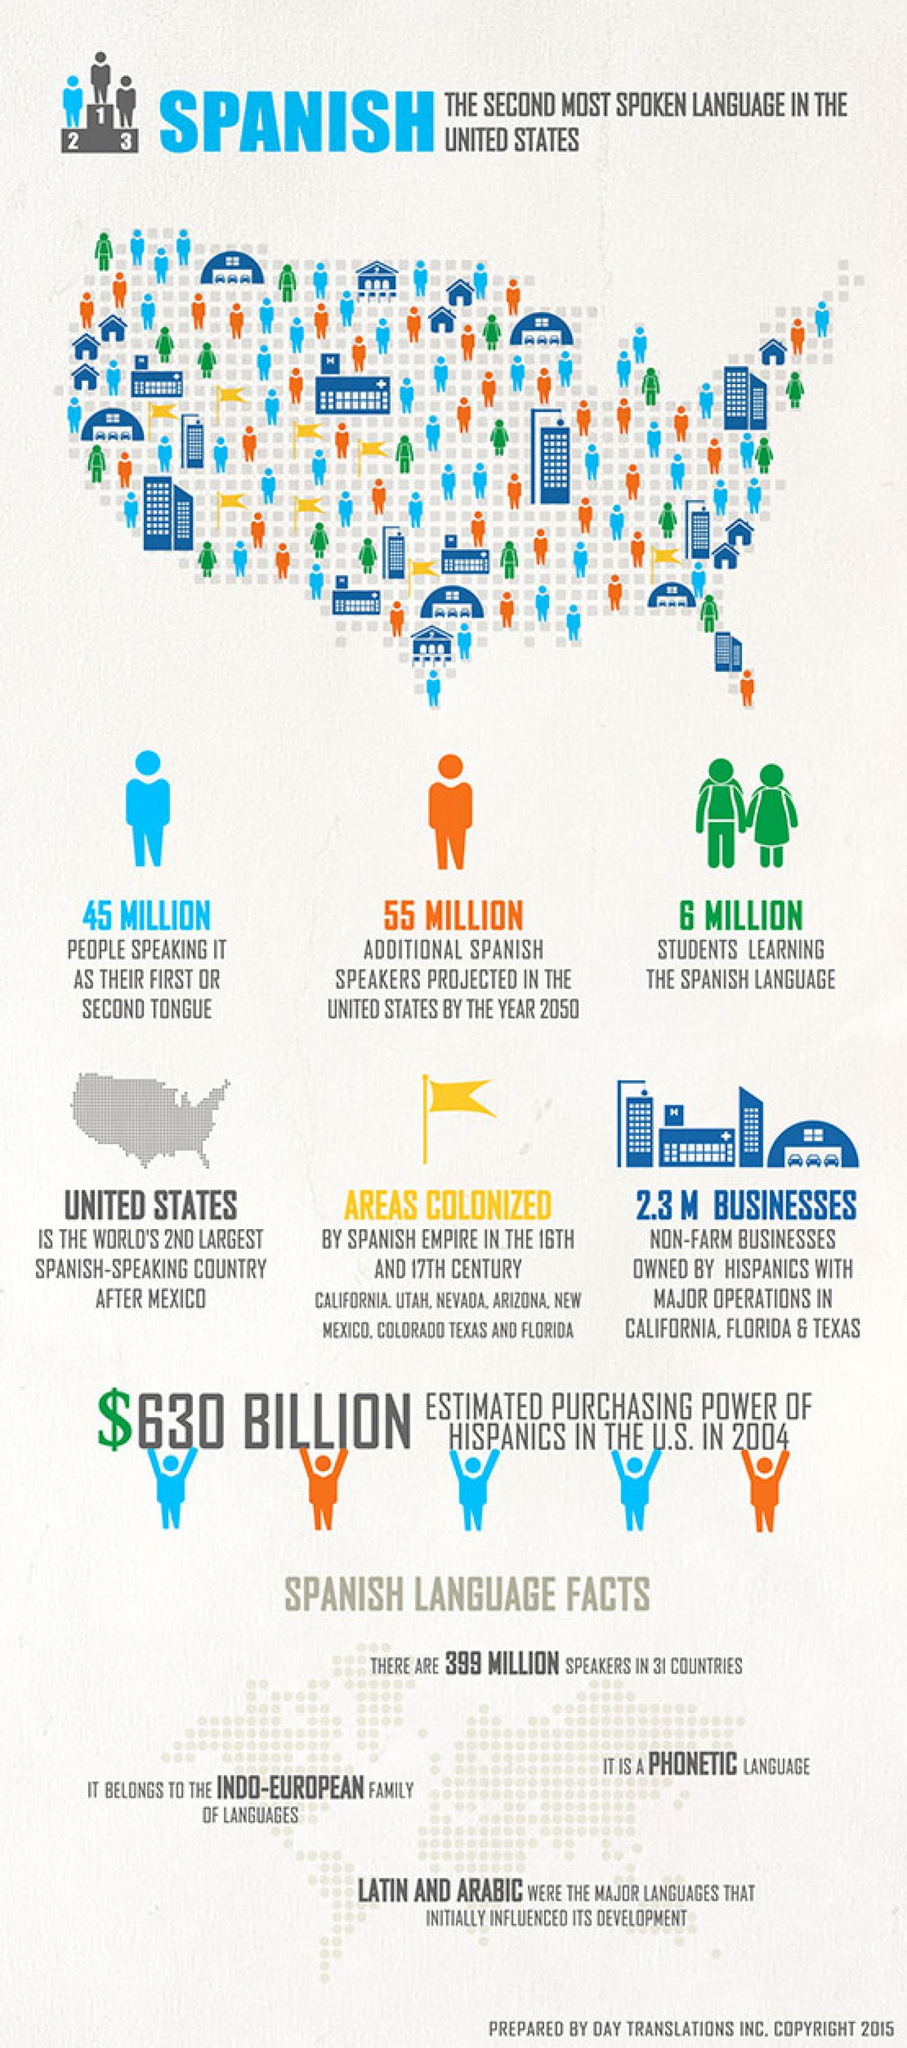Indicate a few pertinent items in this graphic. It is estimated that approximately 55 million students are currently learning the Spanish language worldwide. The United States is the second largest Spanish-speaking country after Mexico. The color of the flag depicted in the image is yellow. According to recent estimates, approximately 45 million people worldwide are considering Spanish as their first or second language. 